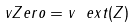<formula> <loc_0><loc_0><loc_500><loc_500>\ v Z e r o = v ^ { \ } e x t ( Z )</formula> 